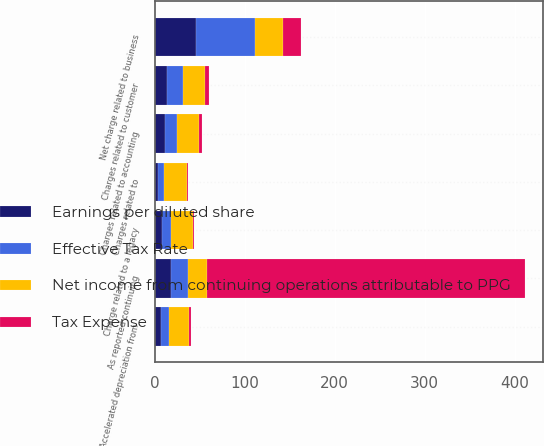Convert chart. <chart><loc_0><loc_0><loc_500><loc_500><stacked_bar_chart><ecel><fcel>As reported continuing<fcel>Charges related to customer<fcel>Charges related to<fcel>Net charge related to business<fcel>Accelerated depreciation from<fcel>Charge related to a legacy<fcel>Charges related to accounting<nl><fcel>Effective Tax Rate<fcel>18.5<fcel>18<fcel>6<fcel>66<fcel>9<fcel>10<fcel>14<nl><fcel>Tax Expense<fcel>353<fcel>4<fcel>2<fcel>20<fcel>2<fcel>2<fcel>3<nl><fcel>Net income from continuing operations attributable to PPG<fcel>20.9<fcel>24.3<fcel>25.5<fcel>30.3<fcel>22.2<fcel>24.3<fcel>24.3<nl><fcel>Earnings per diluted share<fcel>18.5<fcel>14<fcel>4<fcel>46<fcel>7<fcel>8<fcel>11<nl></chart> 